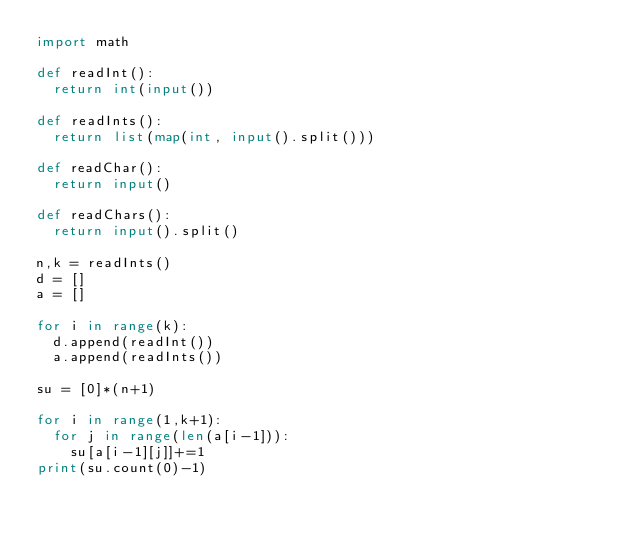Convert code to text. <code><loc_0><loc_0><loc_500><loc_500><_Python_>import math
 
def readInt():
	return int(input())
 
def readInts():
	return list(map(int, input().split()))
 
def readChar():
	return input()

def readChars():
	return input().split()
 
n,k = readInts()
d = []
a = []

for i in range(k):
	d.append(readInt())
	a.append(readInts())

su = [0]*(n+1)

for i in range(1,k+1):
	for j in range(len(a[i-1])):
		su[a[i-1][j]]+=1
print(su.count(0)-1)</code> 